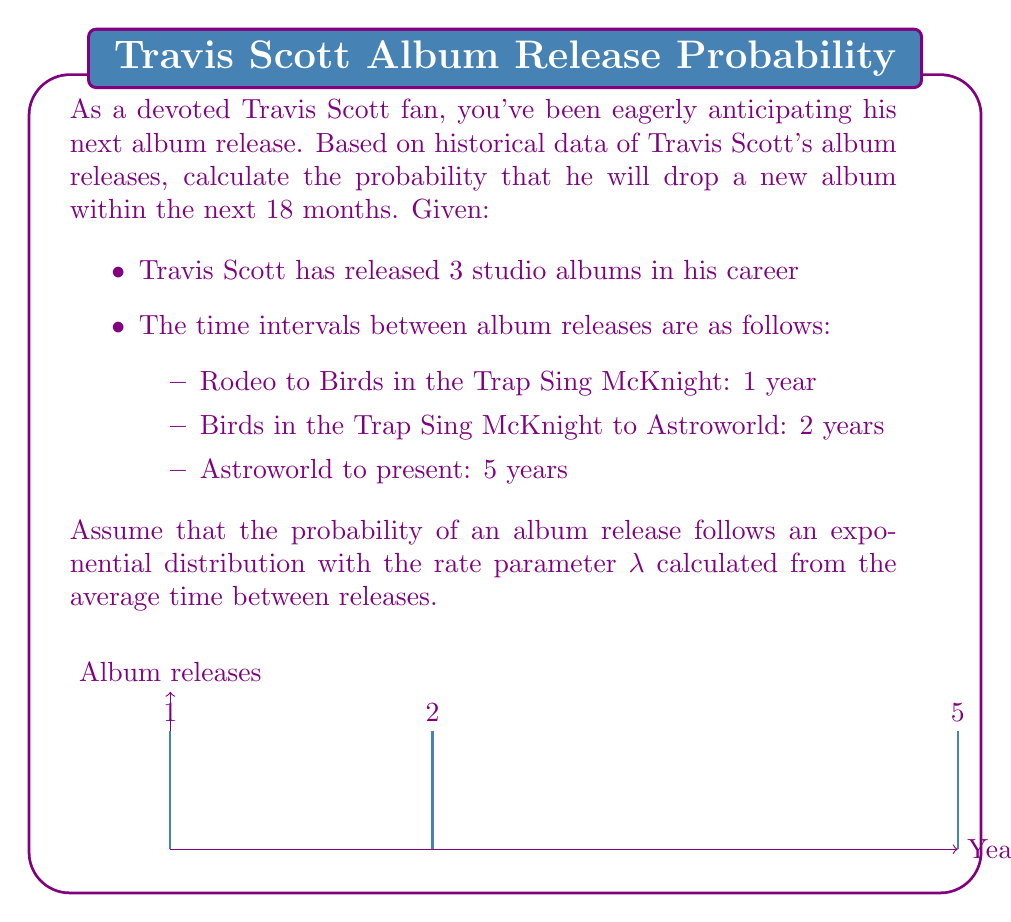Solve this math problem. Let's approach this step-by-step:

1) First, we need to calculate the average time between album releases:
   $$ \text{Average interval} = \frac{1 + 2 + 5}{3} = \frac{8}{3} \approx 2.67 \text{ years} $$

2) The rate parameter λ for the exponential distribution is the inverse of the average interval:
   $$ \lambda = \frac{1}{\text{Average interval}} = \frac{3}{8} \approx 0.375 \text{ per year} $$

3) The probability of an event occurring within time t in an exponential distribution is given by:
   $$ P(T \leq t) = 1 - e^{-\lambda t} $$

4) We want to find the probability for t = 18 months = 1.5 years:
   $$ P(T \leq 1.5) = 1 - e^{-0.375 * 1.5} $$

5) Let's calculate this:
   $$ P(T \leq 1.5) = 1 - e^{-0.5625} $$
   $$ P(T \leq 1.5) = 1 - 0.5697 $$
   $$ P(T \leq 1.5) = 0.4303 $$

6) Convert to a percentage:
   $$ 0.4303 * 100\% = 43.03\% $$
Answer: 43.03% 